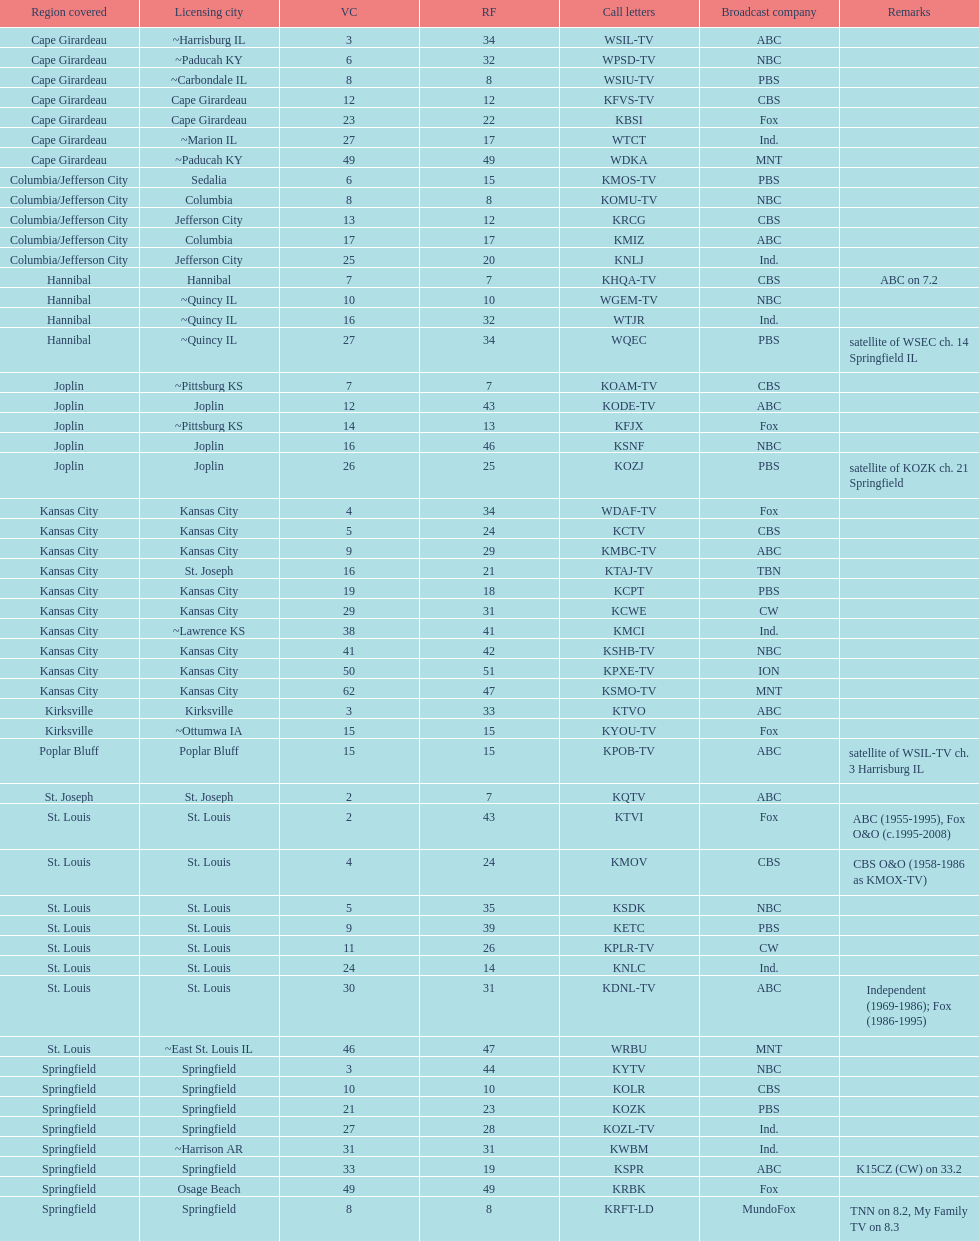What is the total number of cbs stations? 7. 